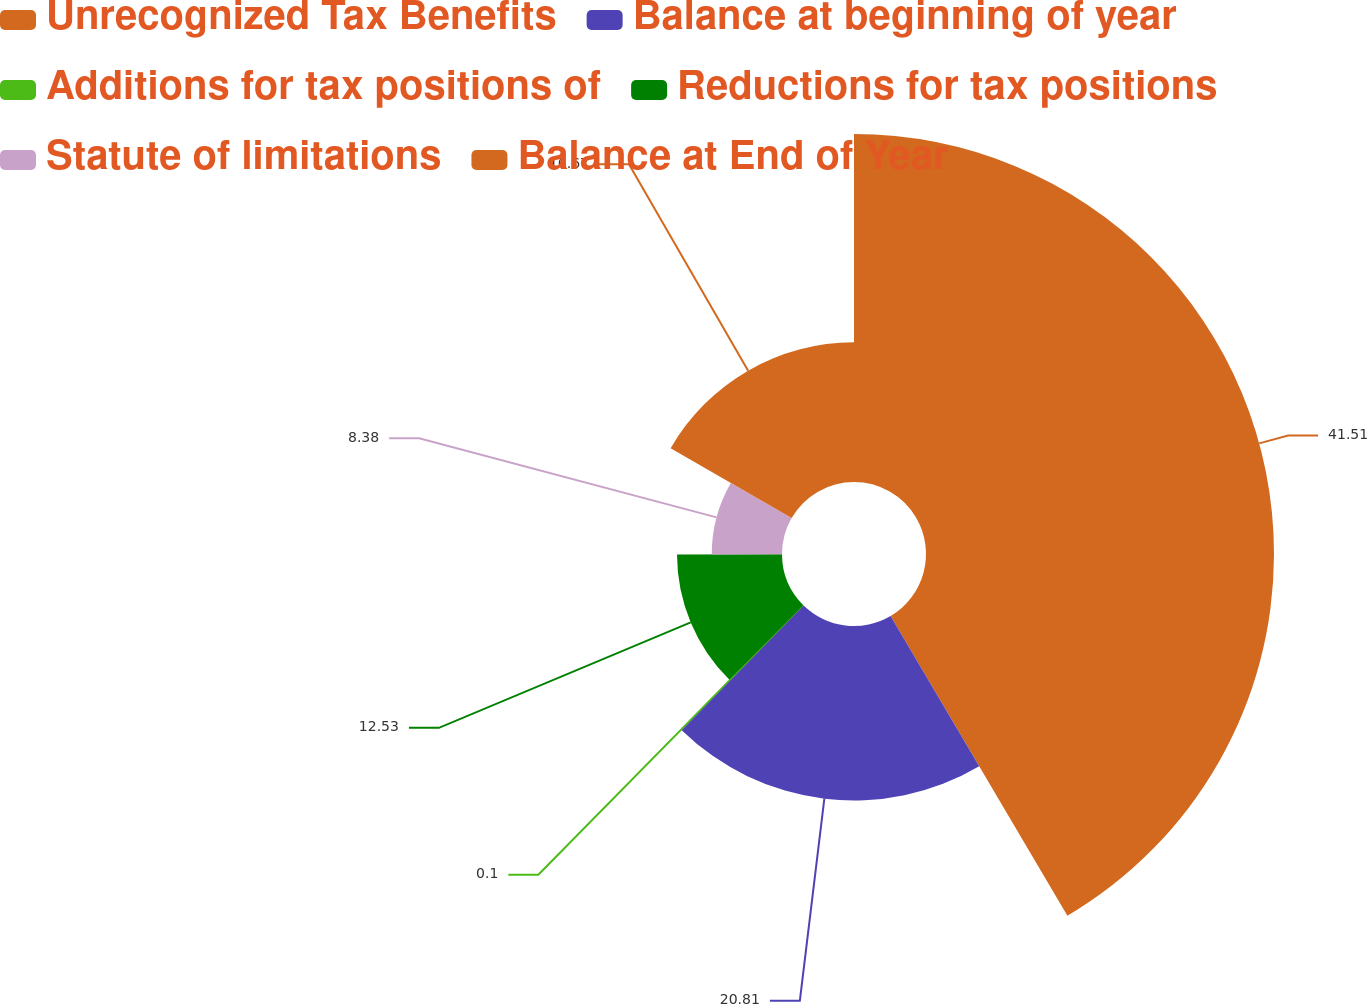<chart> <loc_0><loc_0><loc_500><loc_500><pie_chart><fcel>Unrecognized Tax Benefits<fcel>Balance at beginning of year<fcel>Additions for tax positions of<fcel>Reductions for tax positions<fcel>Statute of limitations<fcel>Balance at End of Year<nl><fcel>41.52%<fcel>20.81%<fcel>0.1%<fcel>12.53%<fcel>8.38%<fcel>16.67%<nl></chart> 